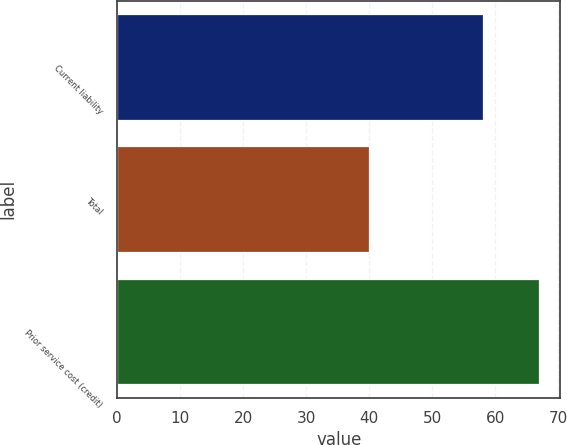Convert chart. <chart><loc_0><loc_0><loc_500><loc_500><bar_chart><fcel>Current liability<fcel>Total<fcel>Prior service cost (credit)<nl><fcel>58<fcel>40<fcel>67<nl></chart> 